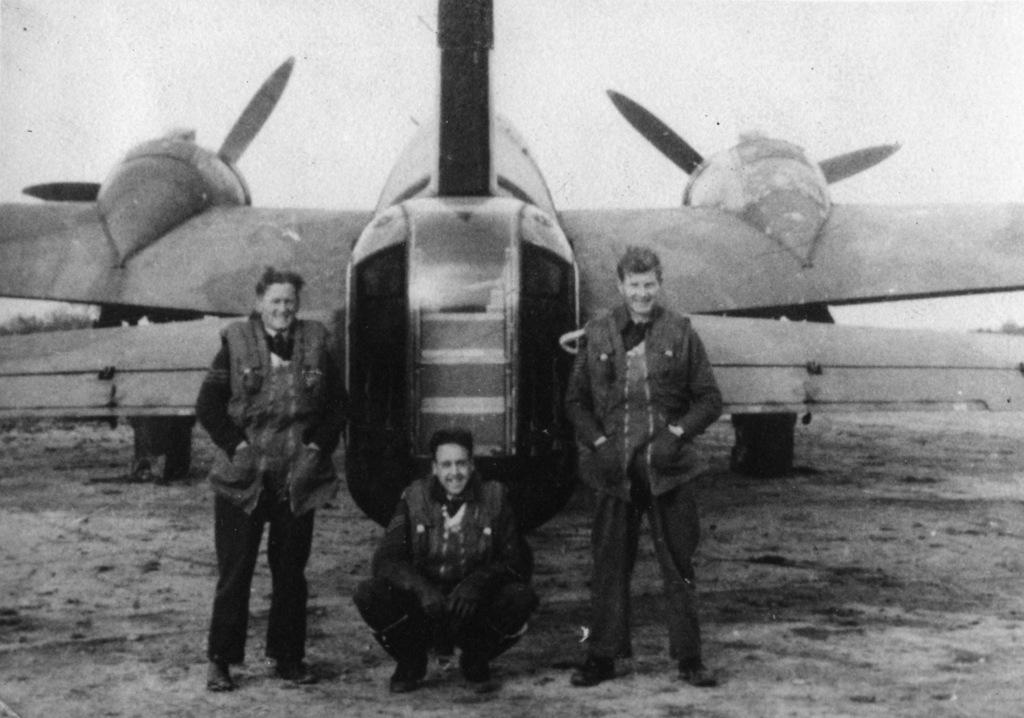What is the color scheme of the image? The image is black and white. What is the main subject of the image? There is an aircraft in the image. How many people are in the image? There are three persons in the image. What is the facial expression of the people in the image? The persons are smiling. What can be seen in the background of the image? There is sky visible in the background of the image. What is visible at the bottom of the image? There is land visible at the bottom of the image. What type of prison can be seen in the image? There is no prison present in the image. What subject are the people teaching in the image? There is no teaching activity depicted in the image. 